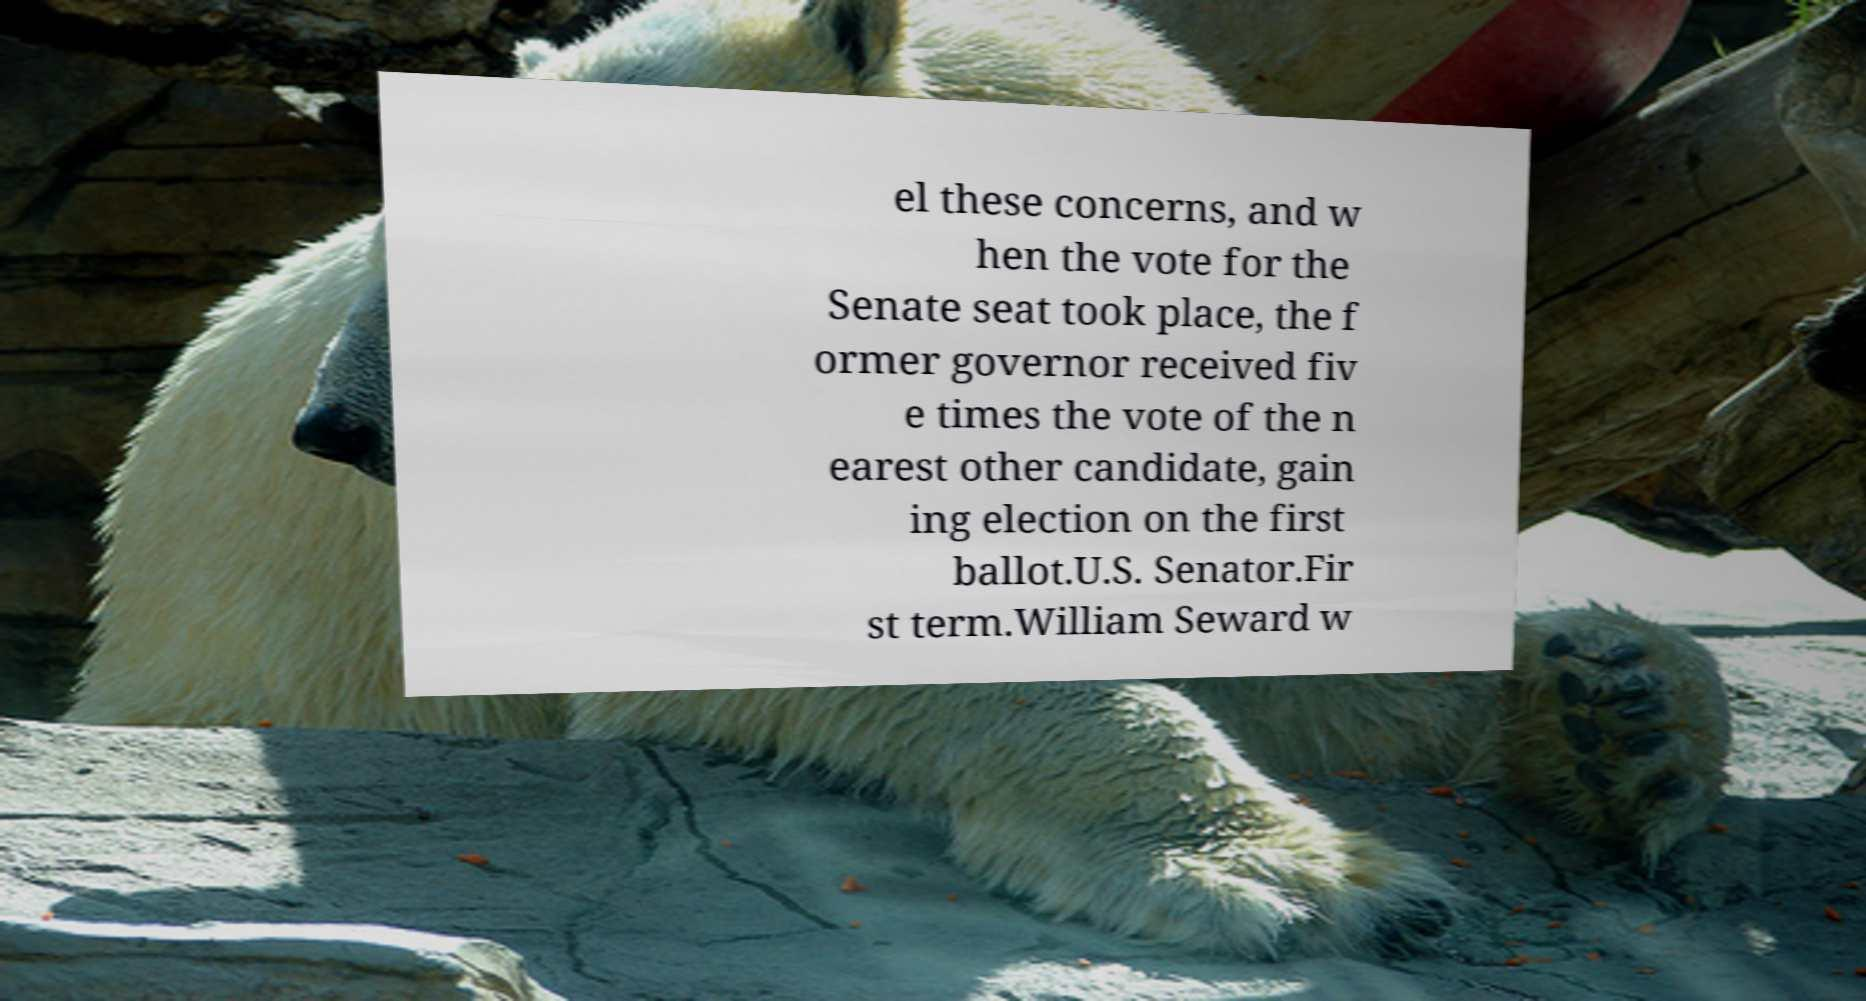For documentation purposes, I need the text within this image transcribed. Could you provide that? el these concerns, and w hen the vote for the Senate seat took place, the f ormer governor received fiv e times the vote of the n earest other candidate, gain ing election on the first ballot.U.S. Senator.Fir st term.William Seward w 